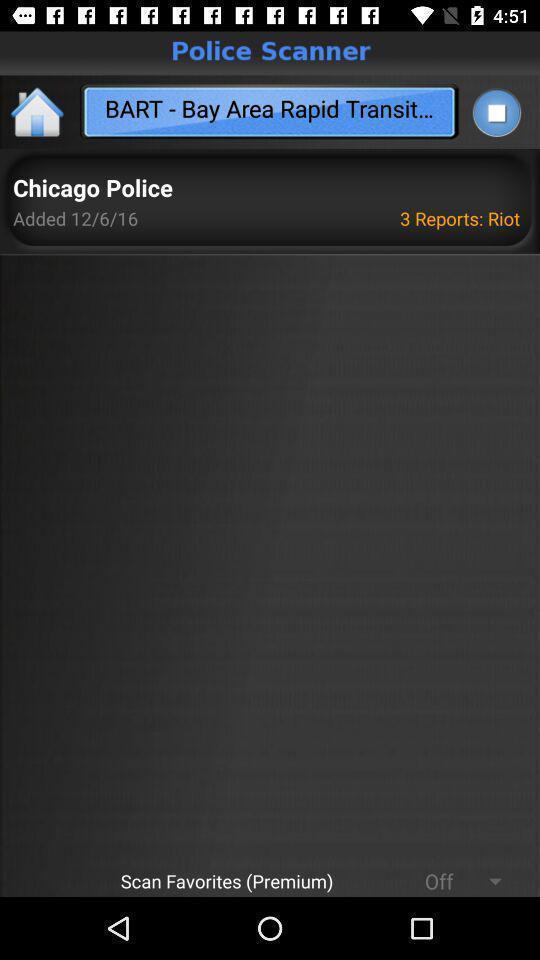What can you discern from this picture? Screen showing reports. 